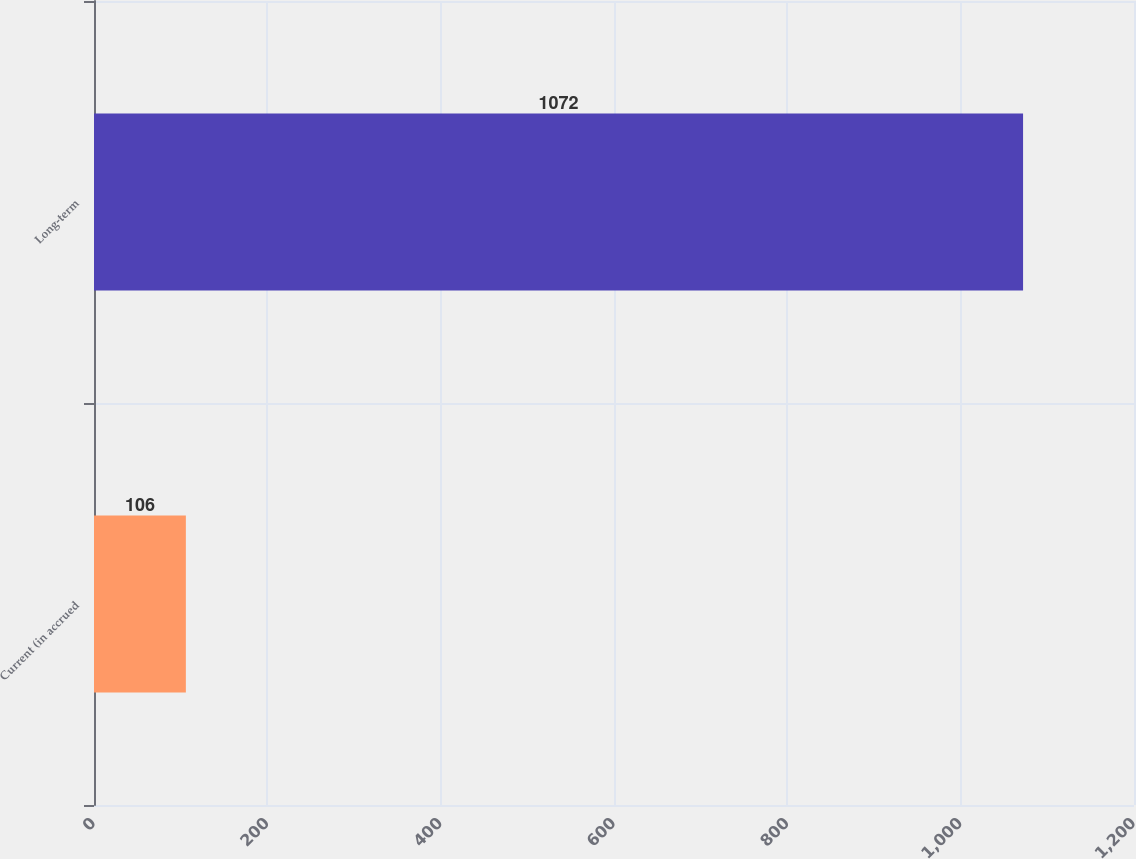Convert chart. <chart><loc_0><loc_0><loc_500><loc_500><bar_chart><fcel>Current (in accrued<fcel>Long-term<nl><fcel>106<fcel>1072<nl></chart> 